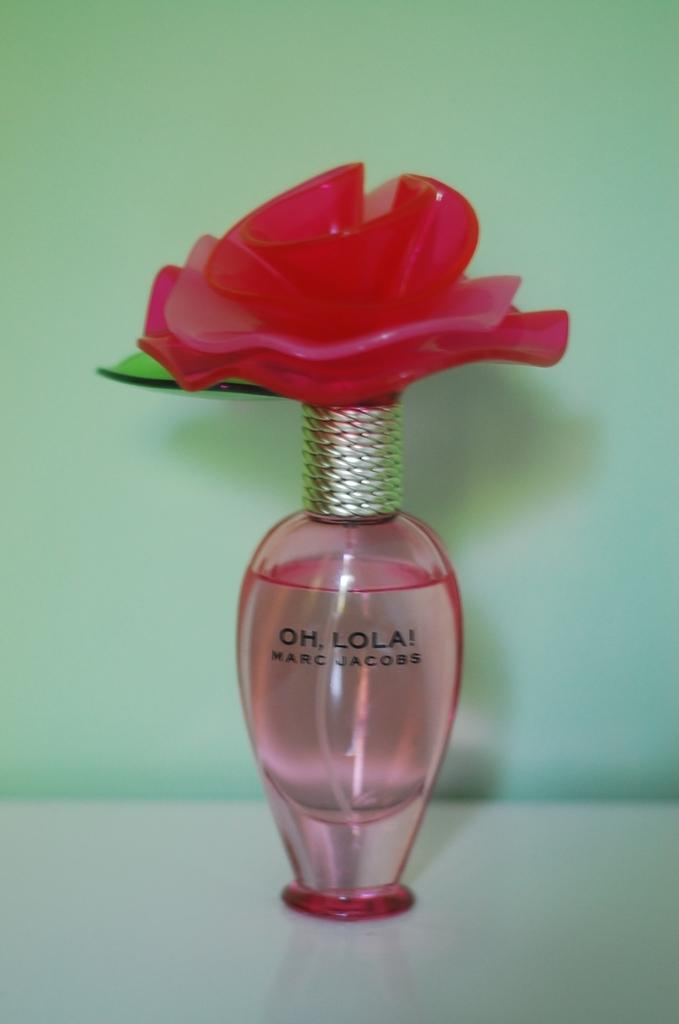Provide a one-sentence caption for the provided image. A Marc Jacobs perfume with a flower on top is on a white surface. 